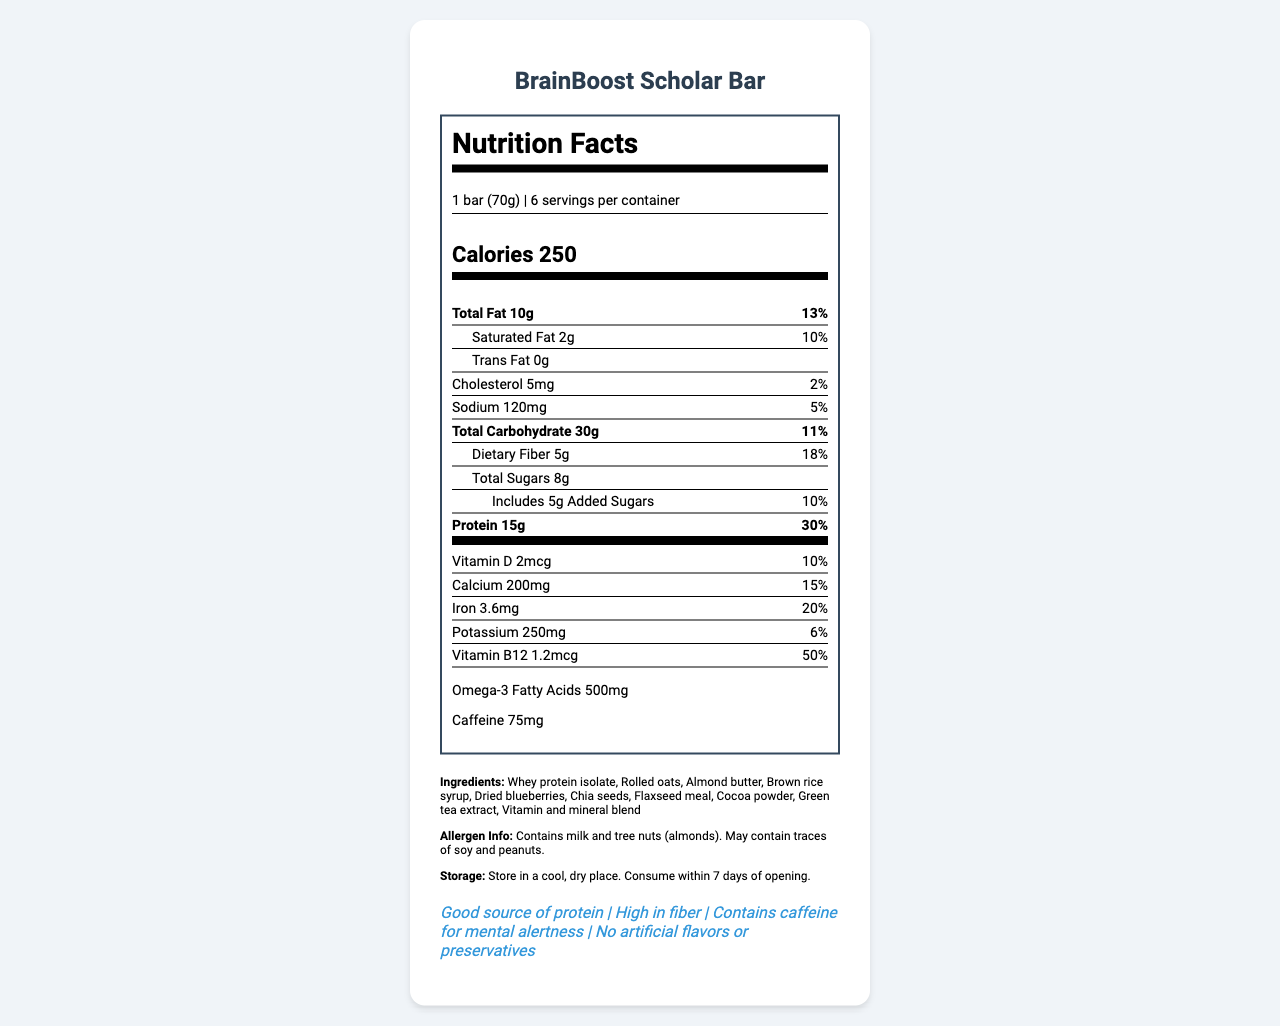what is the serving size of the BrainBoost Scholar Bar? The document states that the serving size is 1 bar, which is equivalent to 70 grams.
Answer: 1 bar (70g) how many calories are in one serving of the BrainBoost Scholar Bar? According to the document, each serving of the BrainBoost Scholar Bar contains 250 calories.
Answer: 250 what is the amount of protein per serving and its daily value percentage? The document indicates that one serving of the BrainBoost Scholar Bar contains 15 grams of protein, which is 30% of the daily value.
Answer: 15g, 30% list three ingredients found in the BrainBoost Scholar Bar. The ingredients list from the document includes whey protein isolate, rolled oats, and almond butter, among others.
Answer: Whey protein isolate, Rolled oats, Almond butter what allergens are present in the BrainBoost Scholar Bar? The allergen information in the document specifies that the product contains milk and tree nuts (almonds).
Answer: Milk and tree nuts (almonds) how much dietary fiber does one bar provide, and what is its daily value percentage? The document reveals that one bar provides 5 grams of dietary fiber, which is 18% of the daily value.
Answer: 5g, 18% which nutrient has the highest daily value percentage in one serving of the BrainBoost Scholar Bar? A. Calcium B. Protein C. Iron D. Vitamin B12 The document shows that Vitamin B12 has a daily value of 50%, which is the highest percentage among the listed nutrients.
Answer: D. Vitamin B12 the BrainBoost Scholar Bar contains caffeine for mental alertness. How much caffeine is in one serving? A. 25mg B. 50mg C. 75mg D. 100mg According to the document, one serving of the BrainBoost Scholar Bar contains 75mg of caffeine.
Answer: C. 75mg true or false: The BrainBoost Scholar Bar contains no artificial flavors or preservatives. The document lists "No artificial flavors or preservatives" as one of the claim statements.
Answer: True summarize the main nutritional benefits of the BrainBoost Scholar Bar. The explanation mentions the key nutritional elements detailed in the document, highlighting the bar's protein, fiber, vitamins, and minerals, as well as caffeine and omega-3 content.
Answer: The BrainBoost Scholar Bar is a nutrient-dense meal replacement option designed for busy graduate students. It provides a good source of protein (15g) with 30% of the daily value, high fiber (5g) with 18% of the daily value, and important vitamins and minerals such as Calcium (15% DV), Iron (20% DV), and Vitamin B12 (50% DV). It also contains beneficial omega-3 fatty acids (500mg) and caffeine (75mg) for mental alertness. The bar avoids artificial flavors and preservatives. how many servings are there in one container of BrainBoost Scholar Bars? The document specifies that there are 6 servings per container.
Answer: 6 which ingredient provides omega-3 fatty acids in the BrainBoost Scholar Bar? The document lists the omega-3 fatty acid content but does not specify which ingredient provides it.
Answer: Cannot be determined 